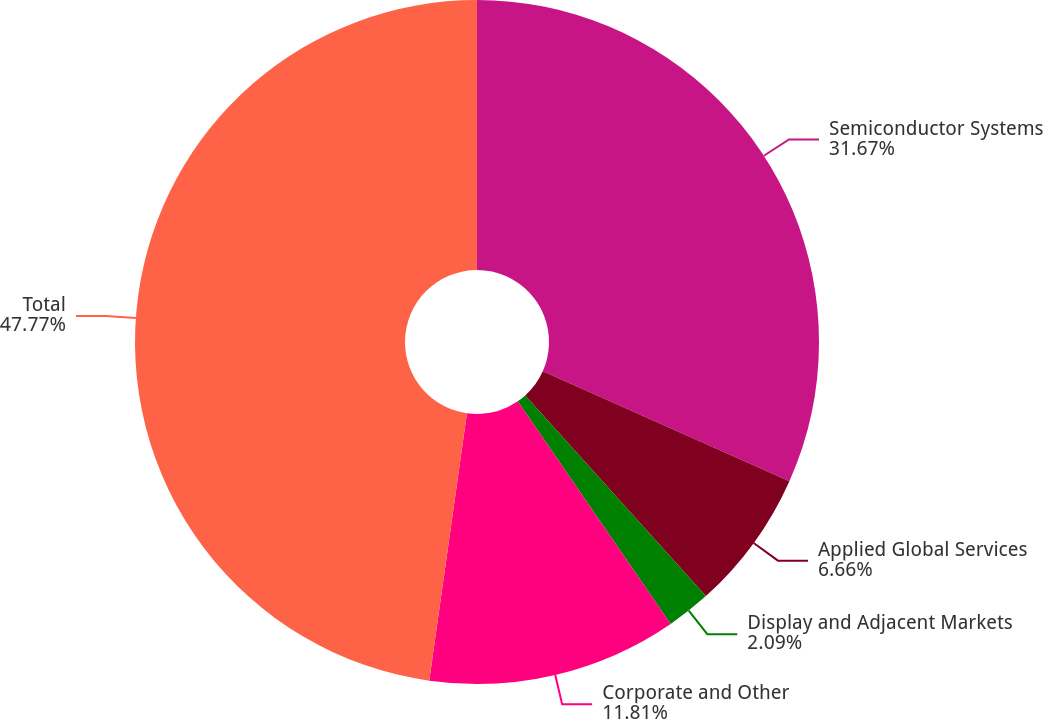<chart> <loc_0><loc_0><loc_500><loc_500><pie_chart><fcel>Semiconductor Systems<fcel>Applied Global Services<fcel>Display and Adjacent Markets<fcel>Corporate and Other<fcel>Total<nl><fcel>31.67%<fcel>6.66%<fcel>2.09%<fcel>11.81%<fcel>47.77%<nl></chart> 